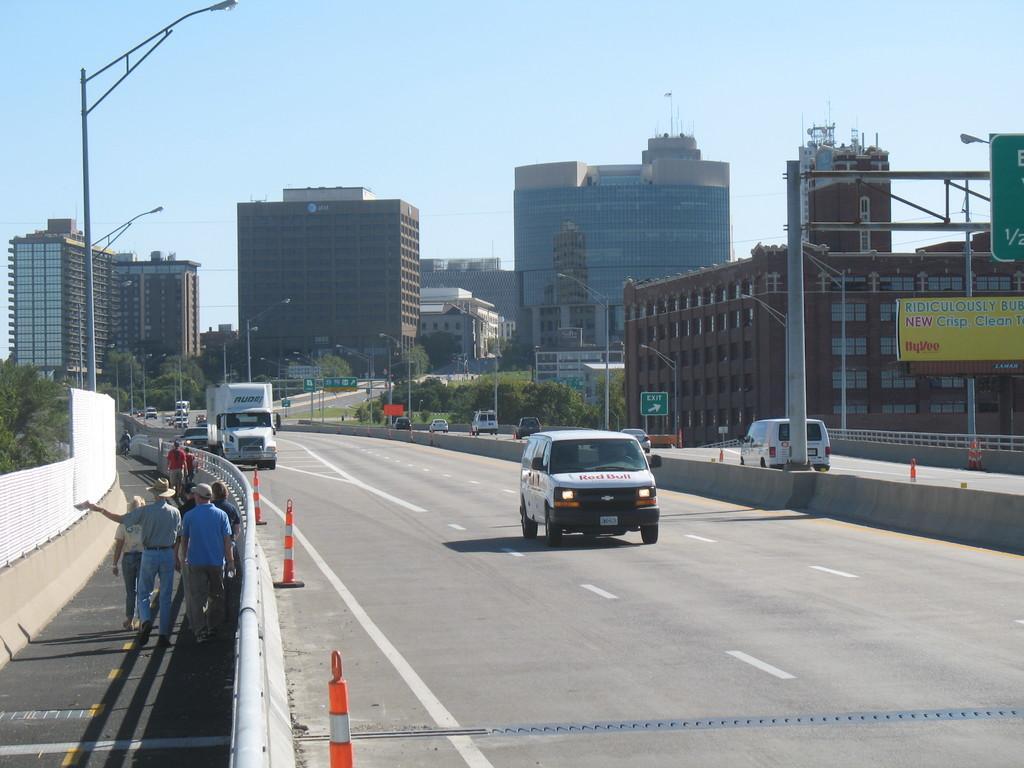Could you give a brief overview of what you see in this image? In this image on both right and center of the image vehicles were travelling on the road and we can see traffic cone cups on the road. At the left side of the image people were walking on the road. At the background there buildings, trees and sky. At the left side there are street lights. 